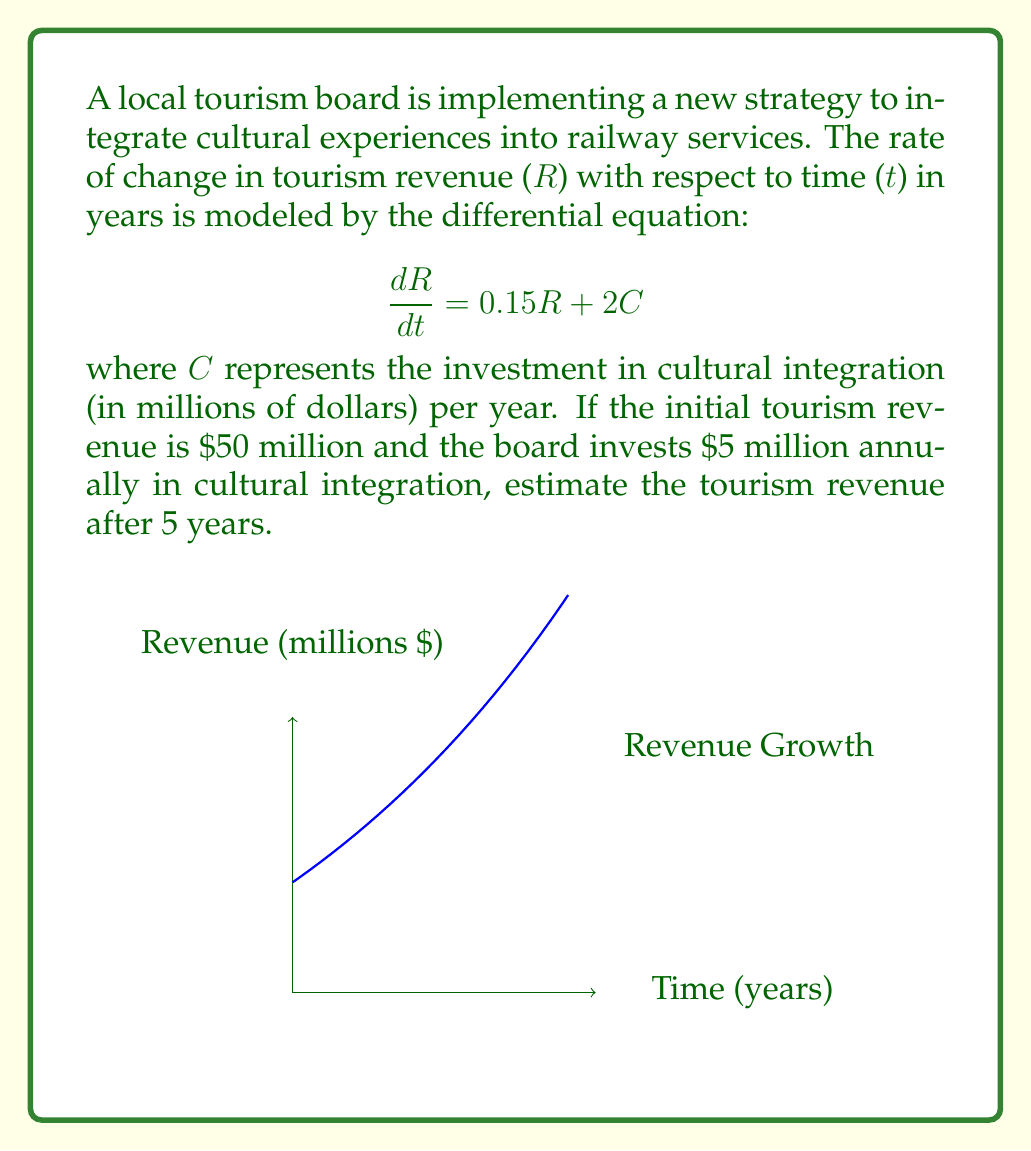Solve this math problem. Let's solve this step-by-step:

1) We have a first-order linear differential equation:
   $$\frac{dR}{dt} = 0.15R + 2C$$

2) The general solution for this type of equation is:
   $$R(t) = e^{0.15t}(R_0 + \int 2Ce^{-0.15t}dt)$$
   where $R_0$ is the initial revenue.

3) Given:
   - Initial revenue $R_0 = 50$ million
   - Constant investment $C = 5$ million per year

4) Substituting these values:
   $$R(t) = e^{0.15t}(50 + \int 10e^{-0.15t}dt)$$

5) Solving the integral:
   $$R(t) = e^{0.15t}(50 + 10[-\frac{1}{0.15}e^{-0.15t}])$$
   $$R(t) = e^{0.15t}(50 - \frac{10}{0.15}e^{-0.15t})$$

6) Simplifying:
   $$R(t) = 50e^{0.15t} - \frac{66.67}{e^{0.15t}} + 66.67$$

7) To find the revenue after 5 years, we substitute t = 5:
   $$R(5) = 50e^{0.15(5)} - \frac{66.67}{e^{0.15(5)}} + 66.67$$

8) Calculating:
   $$R(5) \approx 50(2.1170) - \frac{66.67}{2.1170} + 66.67$$
   $$R(5) \approx 105.85 - 31.49 + 66.67$$
   $$R(5) \approx 141.03$$

Therefore, the estimated tourism revenue after 5 years is approximately $141.03 million.
Answer: $141.03 million 